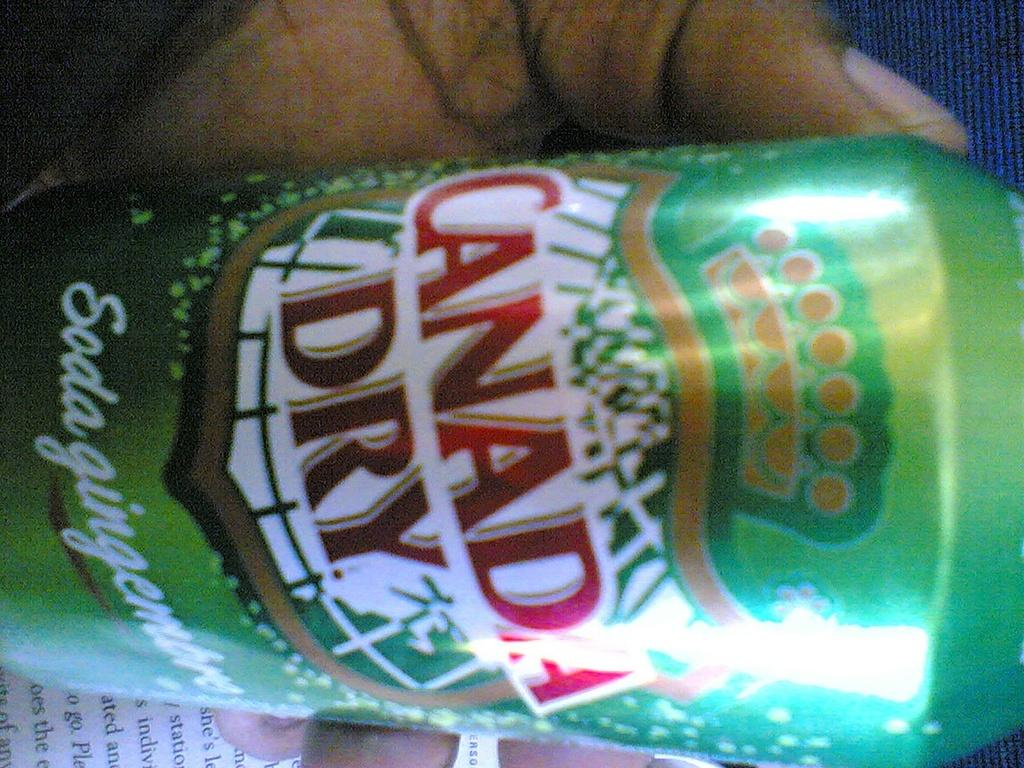Provide a one-sentence caption for the provided image. Someone is holding a can of canada dry soda. 